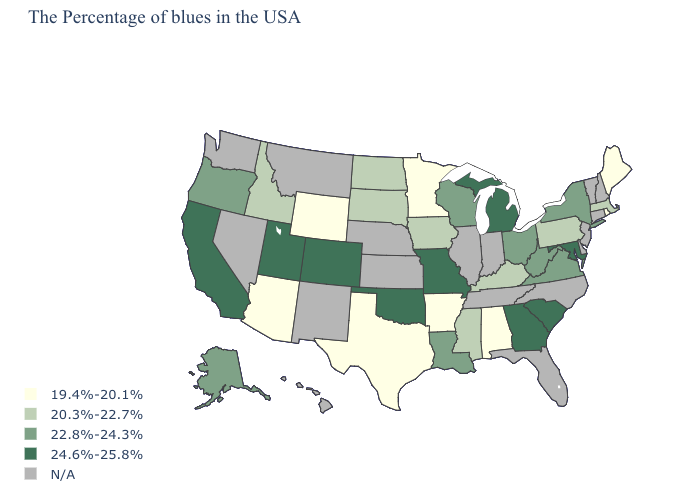What is the lowest value in the USA?
Quick response, please. 19.4%-20.1%. Name the states that have a value in the range 19.4%-20.1%?
Concise answer only. Maine, Rhode Island, Alabama, Arkansas, Minnesota, Texas, Wyoming, Arizona. Does Maine have the lowest value in the USA?
Be succinct. Yes. Which states hav the highest value in the West?
Keep it brief. Colorado, Utah, California. Among the states that border Indiana , does Michigan have the highest value?
Short answer required. Yes. Among the states that border North Dakota , does Minnesota have the highest value?
Short answer required. No. What is the value of Illinois?
Short answer required. N/A. What is the lowest value in the South?
Answer briefly. 19.4%-20.1%. Is the legend a continuous bar?
Keep it brief. No. What is the lowest value in states that border Arkansas?
Quick response, please. 19.4%-20.1%. Which states have the lowest value in the Northeast?
Write a very short answer. Maine, Rhode Island. Name the states that have a value in the range 24.6%-25.8%?
Give a very brief answer. Maryland, South Carolina, Georgia, Michigan, Missouri, Oklahoma, Colorado, Utah, California. What is the value of Utah?
Quick response, please. 24.6%-25.8%. What is the value of Louisiana?
Be succinct. 22.8%-24.3%. What is the value of Virginia?
Concise answer only. 22.8%-24.3%. 